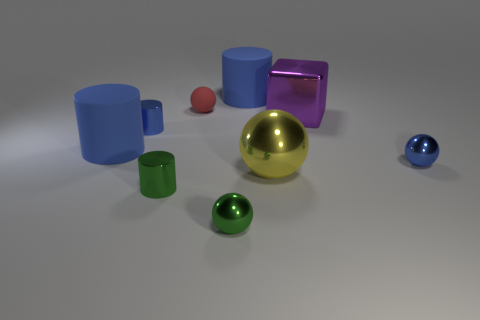Subtract all red spheres. How many blue cylinders are left? 3 Add 1 tiny green rubber balls. How many objects exist? 10 Subtract all cylinders. How many objects are left? 5 Add 9 purple shiny objects. How many purple shiny objects are left? 10 Add 8 shiny cylinders. How many shiny cylinders exist? 10 Subtract 0 purple cylinders. How many objects are left? 9 Subtract all blue matte cylinders. Subtract all large metallic things. How many objects are left? 5 